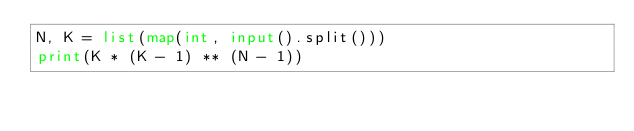Convert code to text. <code><loc_0><loc_0><loc_500><loc_500><_Python_>N, K = list(map(int, input().split()))
print(K * (K - 1) ** (N - 1))</code> 